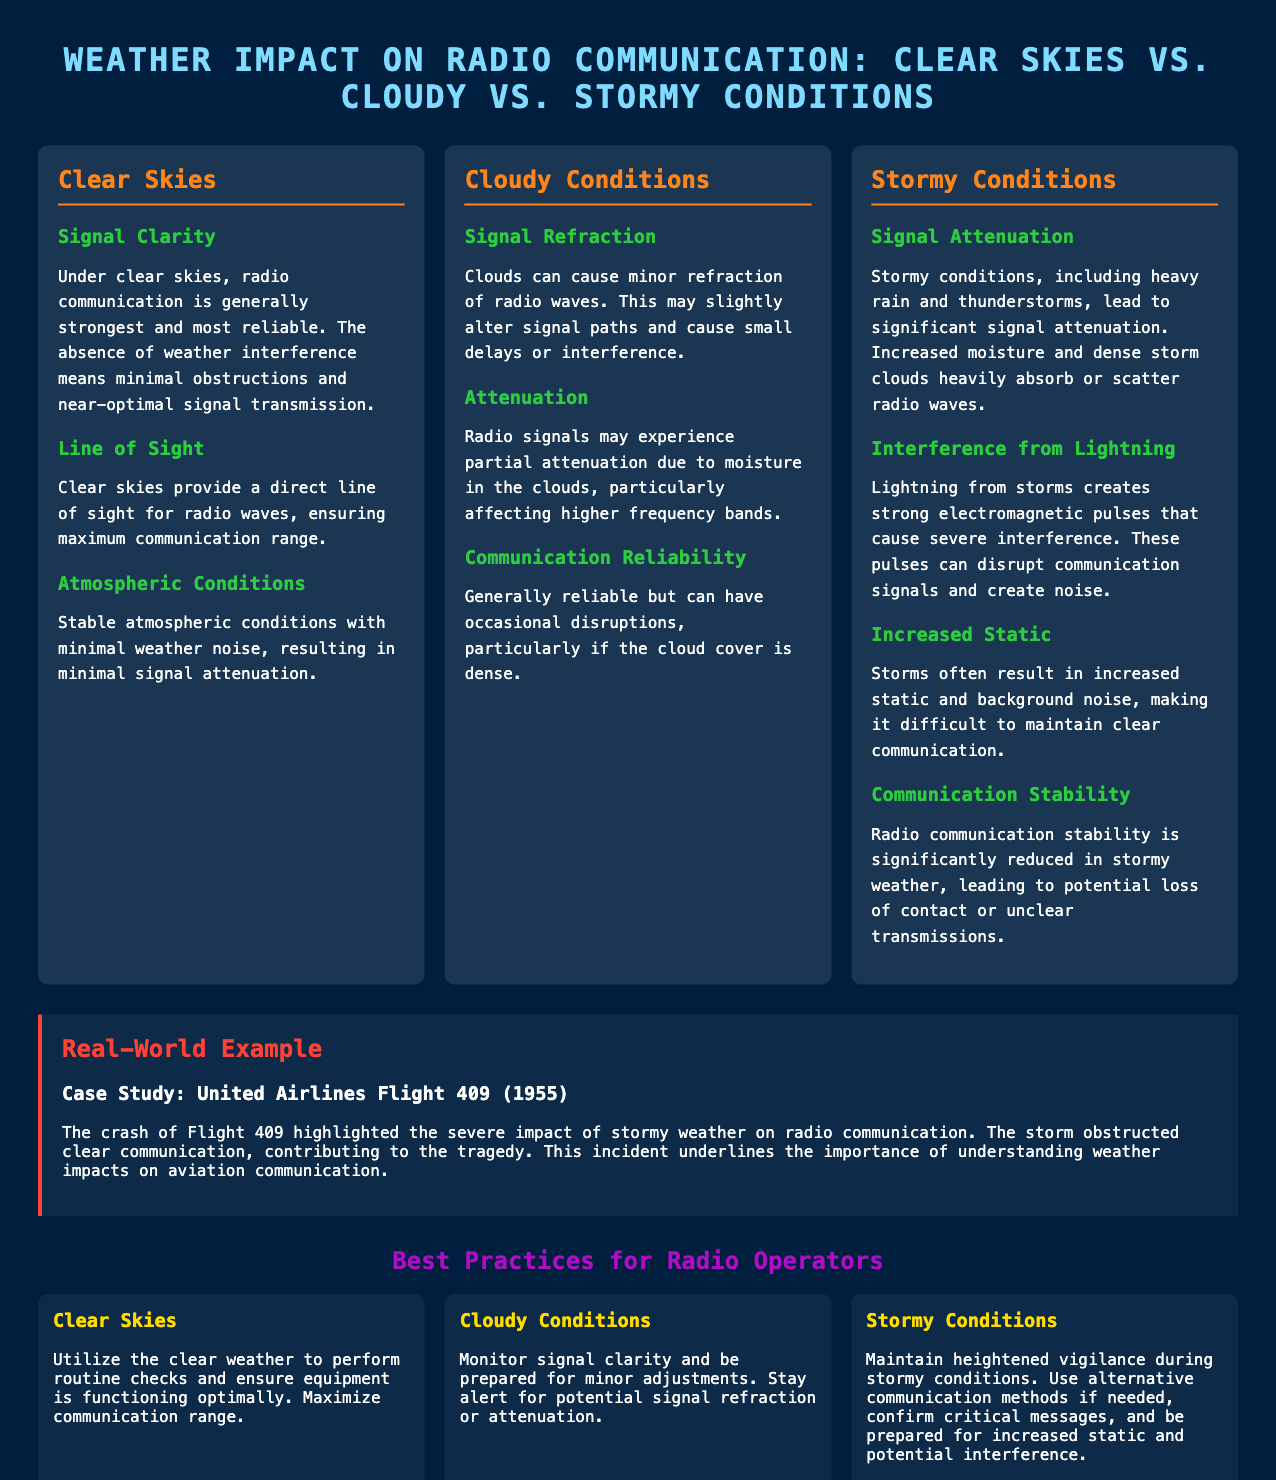what is the main title of the document? The main title summarizes the document's subject matter, reflecting its focus on different weather conditions and their effects on radio communication.
Answer: Weather Impact on Radio Communication: Clear Skies vs. Cloudy vs. Stormy Conditions what does "Signal Clarity" refer to in clear skies? "Signal Clarity" in clear skies highlights the condition that allows for the strongest and most reliable radio communication without weather interference.
Answer: Strongest and most reliable how does cloudy weather affect radio signals? The document states that cloudy conditions result in signal refraction and partial attenuation, which affects radio signals.
Answer: Refraction and partial attenuation what increased phenomenon is mentioned for stormy conditions? The document indicates that storms lead to increased static and background noise, impacting the clarity of communication.
Answer: Increased static which weather condition has the least reliable communication? The document details that stormy conditions significantly reduce radio communication stability, indicating the least reliability.
Answer: Stormy Conditions what was the case study mentioned in the document? The case study referring to a real-world example illustrates the impact of weather on communication, specifically mentioning a flight incident.
Answer: United Airlines Flight 409 (1955) what advice is given for radio operators during stormy conditions? The document provides best practices for maintaining communication during stormy weather, emphasizing vigilance and alternative methods.
Answer: Maintain heightened vigilance which factor leads to minimal signal attenuation under clear skies? The document specifies that stable atmospheric conditions under clear skies contribute to minimal signal attenuation.
Answer: Stable atmospheric conditions how do clouds impact signal paths? According to the document, clouds can cause minor refraction, which alters signal paths slightly.
Answer: Minor refraction 